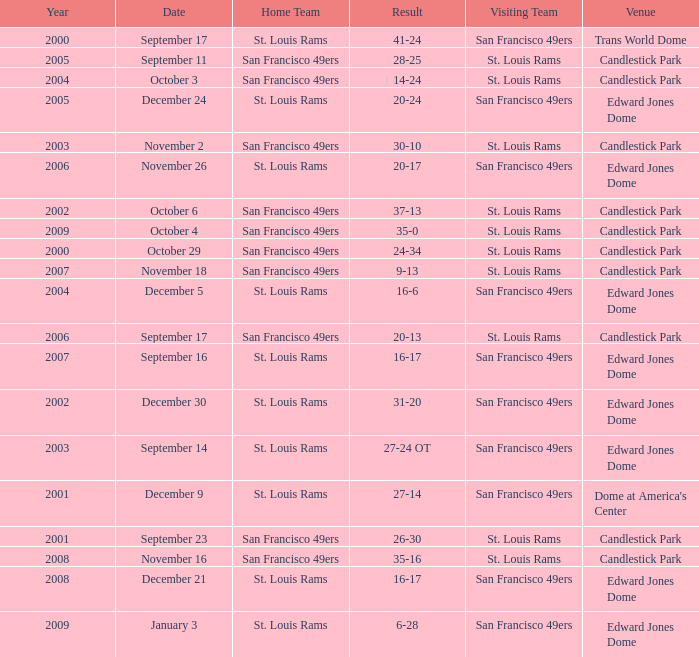What is the Result of the game on October 3? 14-24. 